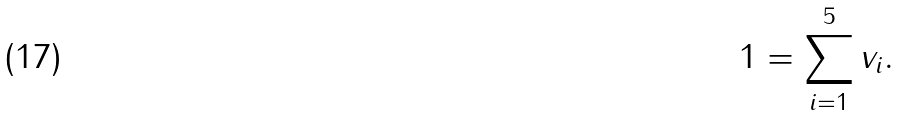Convert formula to latex. <formula><loc_0><loc_0><loc_500><loc_500>1 = \sum _ { i = 1 } ^ { 5 } v _ { i } .</formula> 